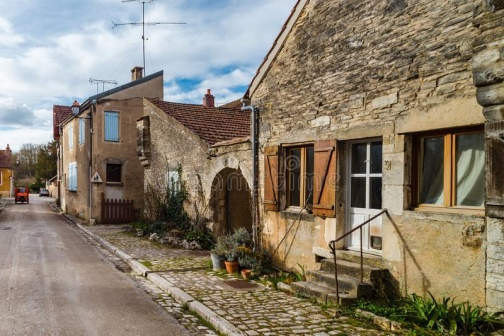What might be the daily life like for residents in this village? Residents of this village likely experience a peaceful, community-oriented lifestyle, with daily routines that are deeply intertwined with their surroundings. The narrow streets and close-knit buildings suggest a compact living space, encouraging interactions among neighbors. The presence of potted plants and well-maintained exteriors indicates a pride in home aesthetics and a connection to nature. Daily life may center around local traditions, seasonal activities, and a slower pace of life that allows for enjoying the simple pleasures of a close community setting. 